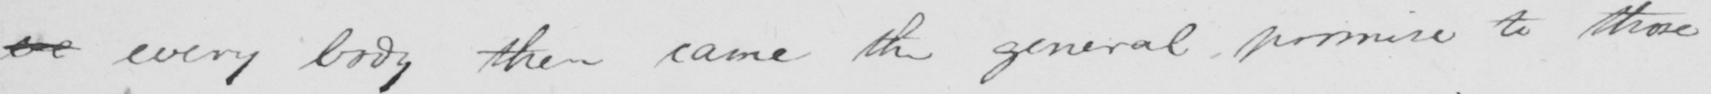Please transcribe the handwritten text in this image. eve every body then came the general promise to those 